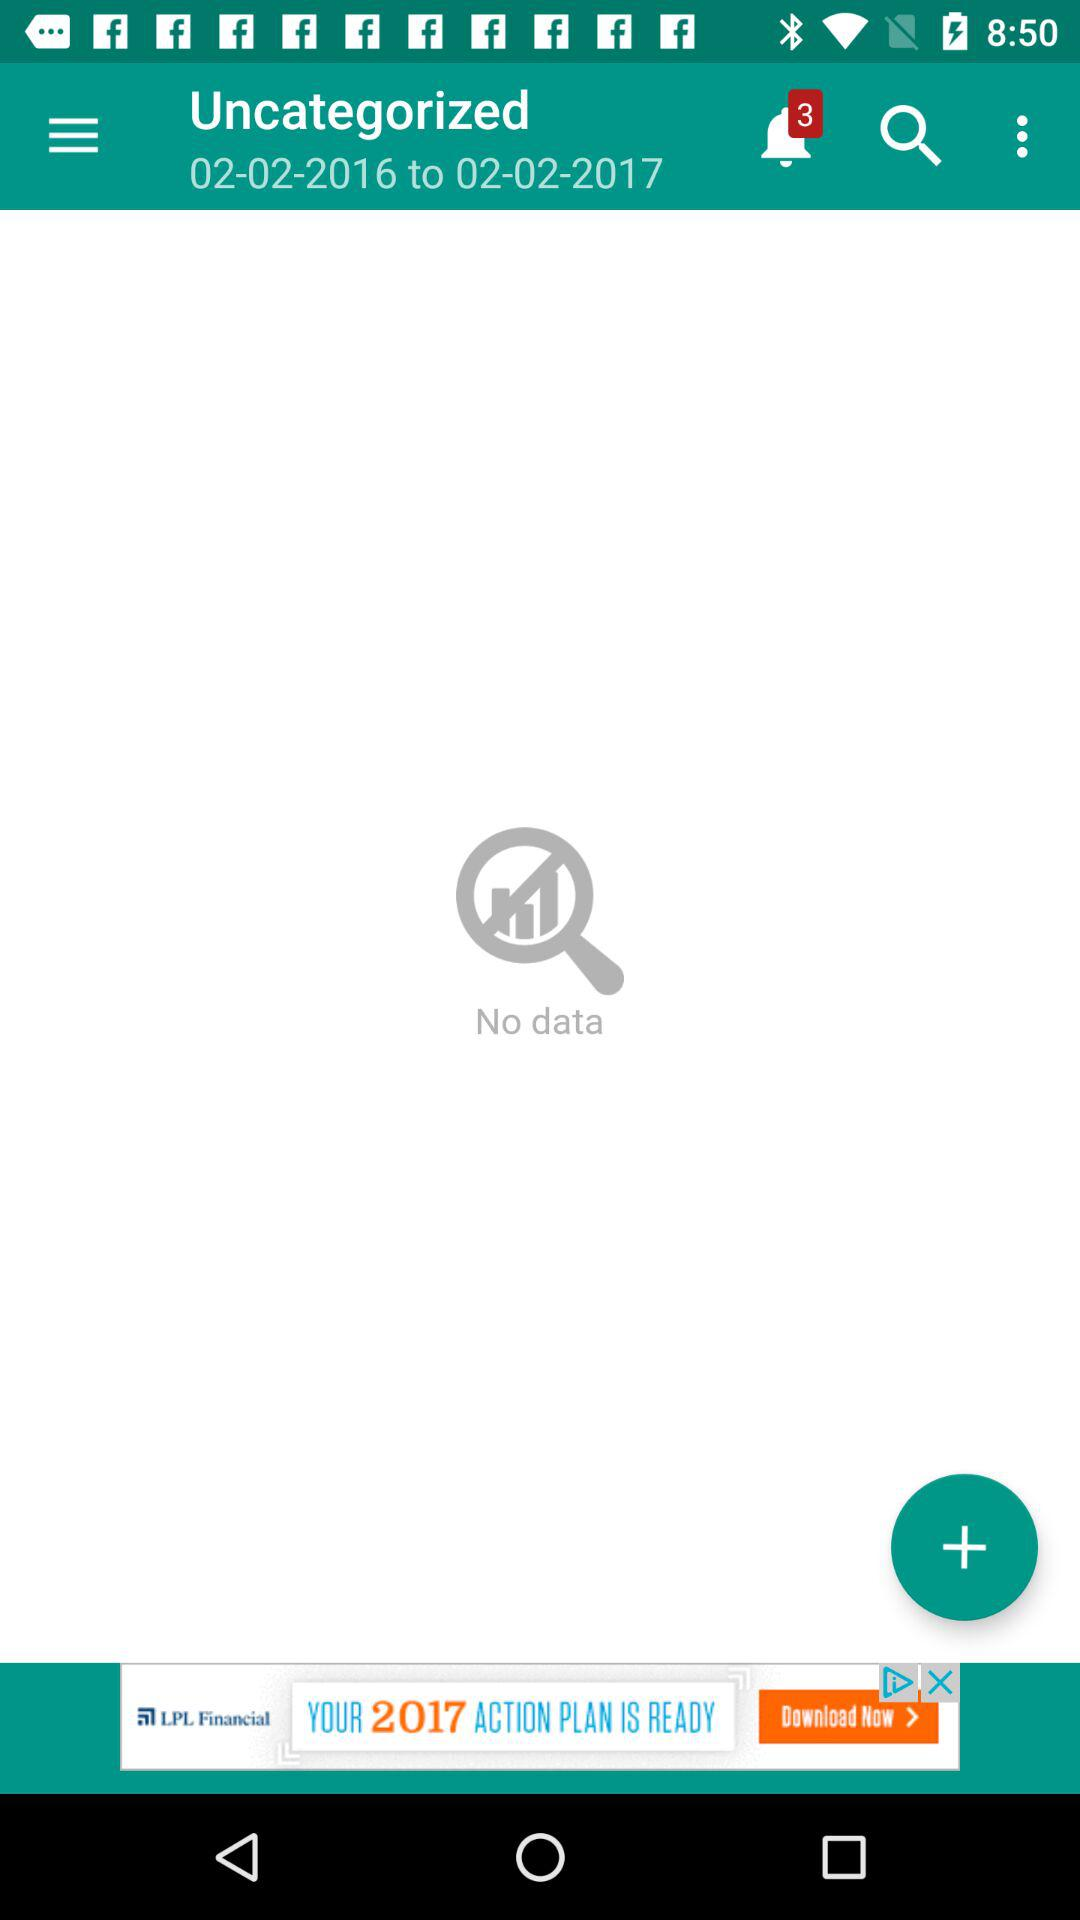Which date range is the data given for? The date range is from February 2, 2016 to February 2, 2017. 